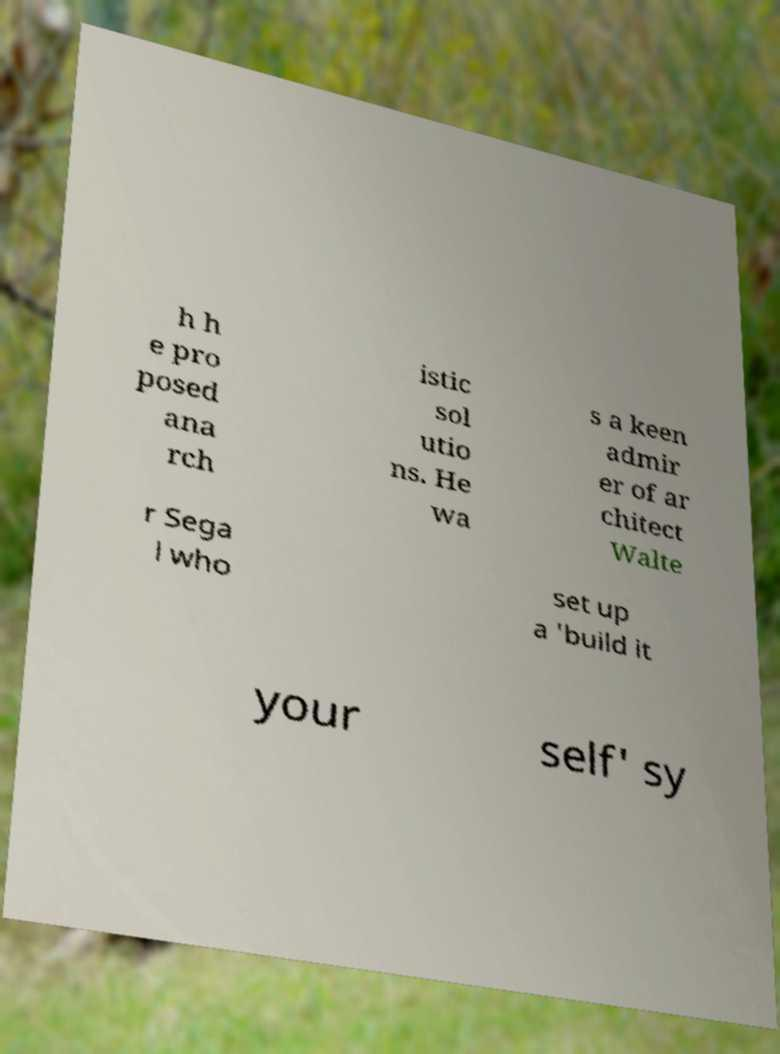For documentation purposes, I need the text within this image transcribed. Could you provide that? h h e pro posed ana rch istic sol utio ns. He wa s a keen admir er of ar chitect Walte r Sega l who set up a 'build it your self' sy 